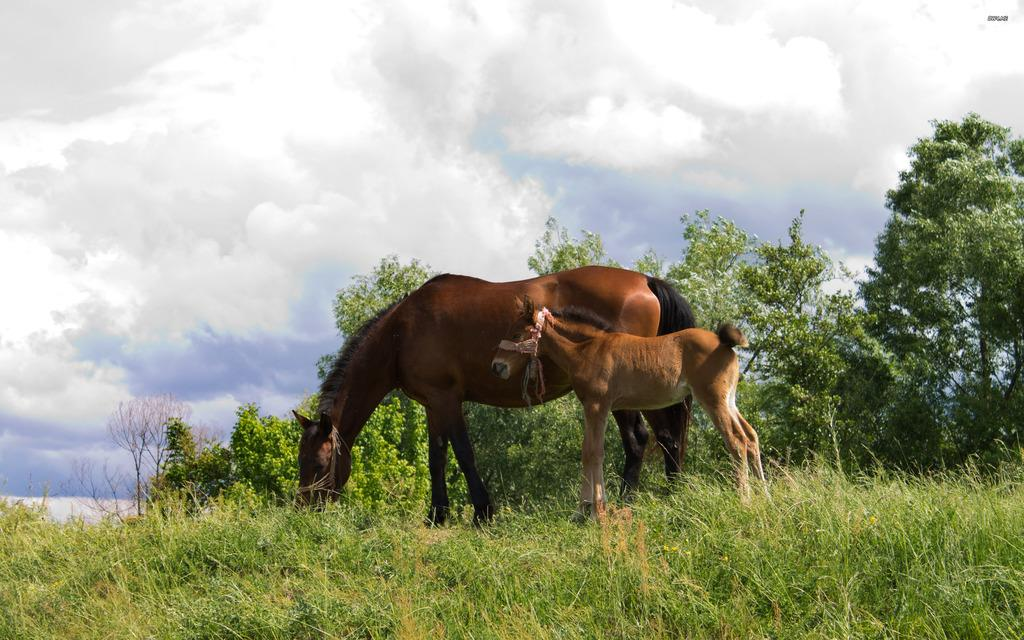How many animals are present in the image? There are two animals in the image. What are the animals doing in the image? One animal is grazing the grass, while the other animal is standing. What type of terrain can be seen in the image? The animals are standing on grassland. What is visible in the background of the image? There are trees in the background of the image. What is visible at the top of the image? The sky is visible at the top of the image, and there are clouds in the sky. What type of authority figure can be seen in the image? There is no authority figure present in the image; it features two animals on grassland with trees and clouds in the background. What kind of glue is being used by the animals in the image? There is no glue present in the image; the animals are standing and grazing on grass. 